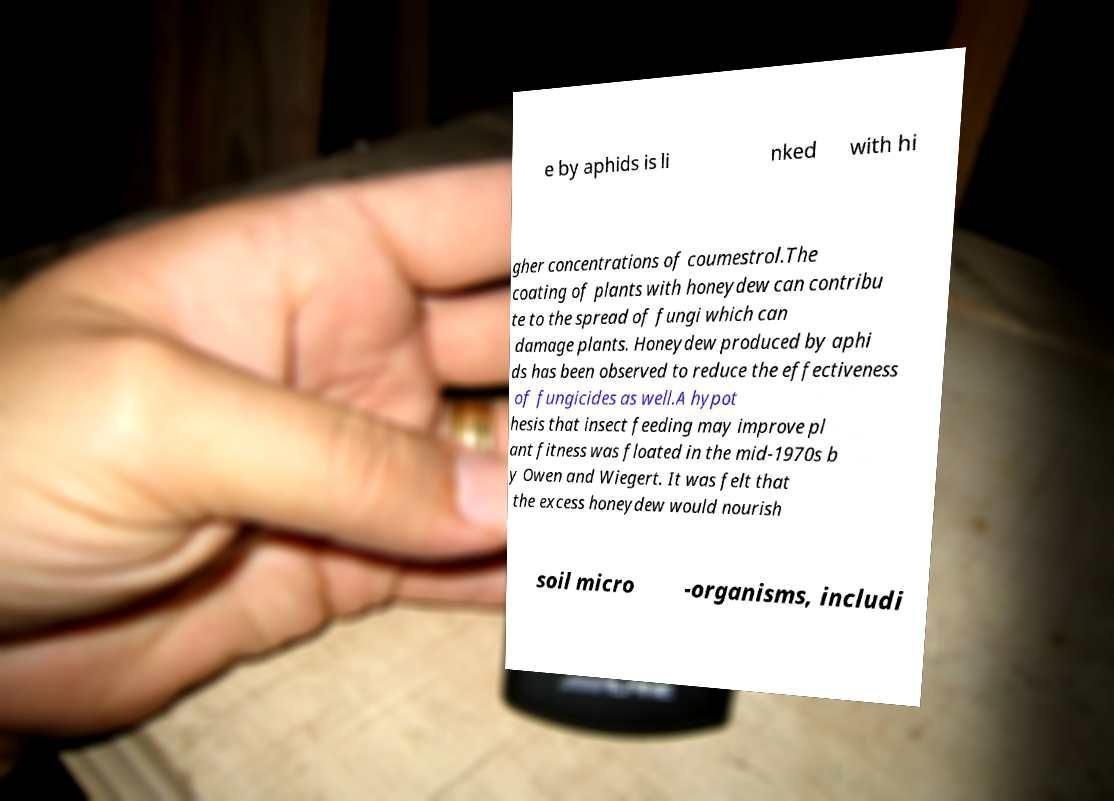What messages or text are displayed in this image? I need them in a readable, typed format. e by aphids is li nked with hi gher concentrations of coumestrol.The coating of plants with honeydew can contribu te to the spread of fungi which can damage plants. Honeydew produced by aphi ds has been observed to reduce the effectiveness of fungicides as well.A hypot hesis that insect feeding may improve pl ant fitness was floated in the mid-1970s b y Owen and Wiegert. It was felt that the excess honeydew would nourish soil micro -organisms, includi 